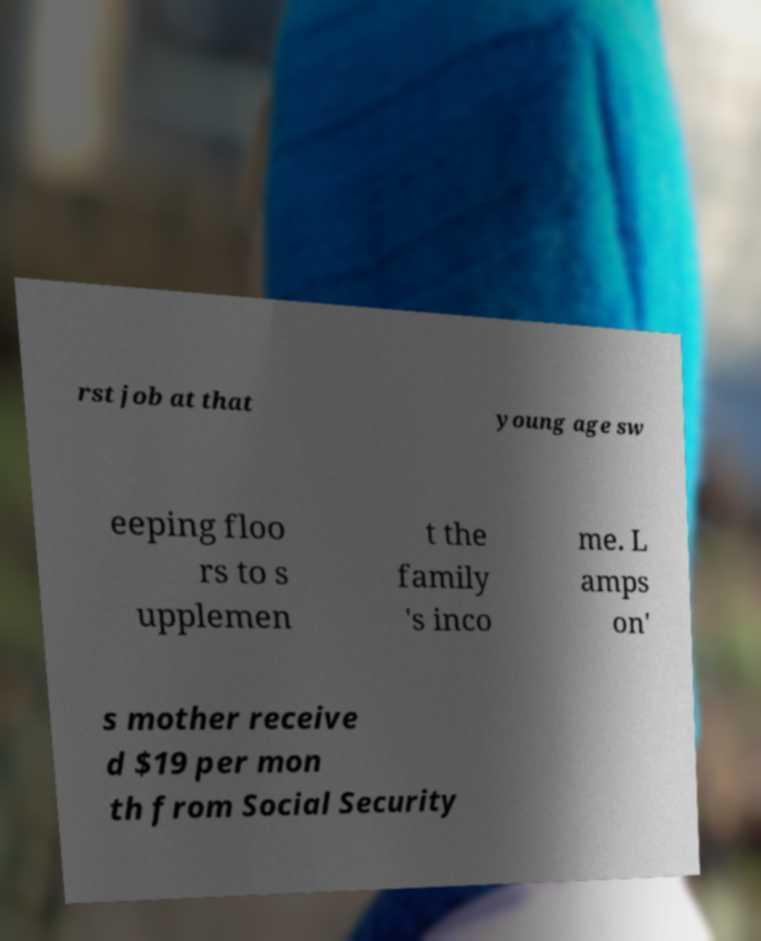Could you extract and type out the text from this image? rst job at that young age sw eeping floo rs to s upplemen t the family 's inco me. L amps on' s mother receive d $19 per mon th from Social Security 